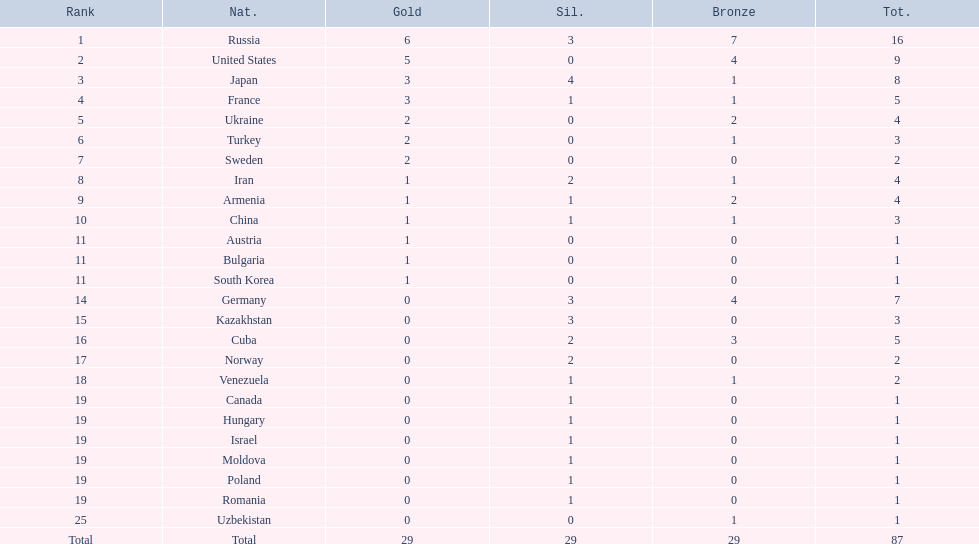Which countries competed in the 1995 world wrestling championships? Russia, United States, Japan, France, Ukraine, Turkey, Sweden, Iran, Armenia, China, Austria, Bulgaria, South Korea, Germany, Kazakhstan, Cuba, Norway, Venezuela, Canada, Hungary, Israel, Moldova, Poland, Romania, Uzbekistan. What country won only one medal? Austria, Bulgaria, South Korea, Canada, Hungary, Israel, Moldova, Poland, Romania, Uzbekistan. Which of these won a bronze medal? Uzbekistan. 